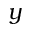<formula> <loc_0><loc_0><loc_500><loc_500>y</formula> 